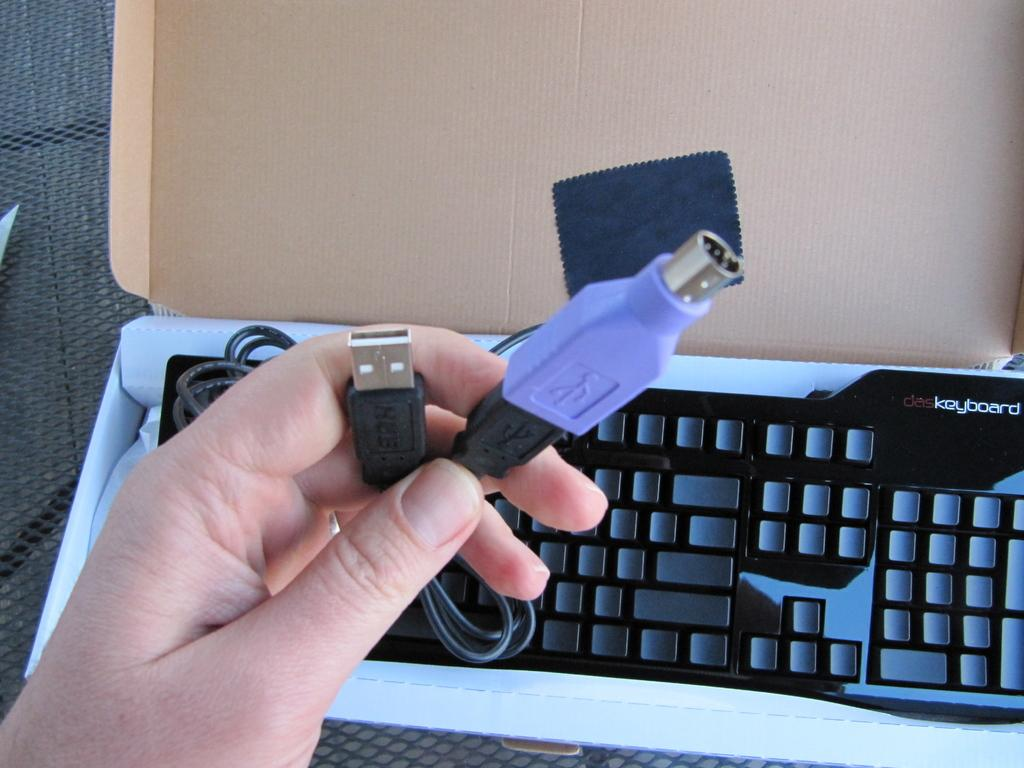What can be seen in the image that is related to technology? There is a cable and a keyboard visible in the image. What part of a person can be seen in the image? A person's hand is visible in the image. What material is present in the image that is typically used for packaging or crafts? There is cardboard in the image. What is the color of the background in the image? The background of the image is black. What type of magic trick is being performed with the egg in the image? There is no egg present in the image, so no magic trick can be observed. What kind of apparatus is being used to perform the magic trick in the image? There is no magic trick or apparatus present in the image. 